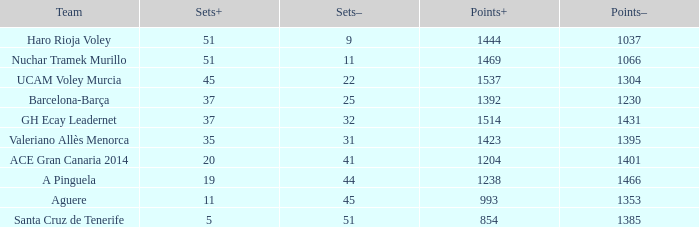What is the total number of Points- when the Sets- is larger than 51? 0.0. 